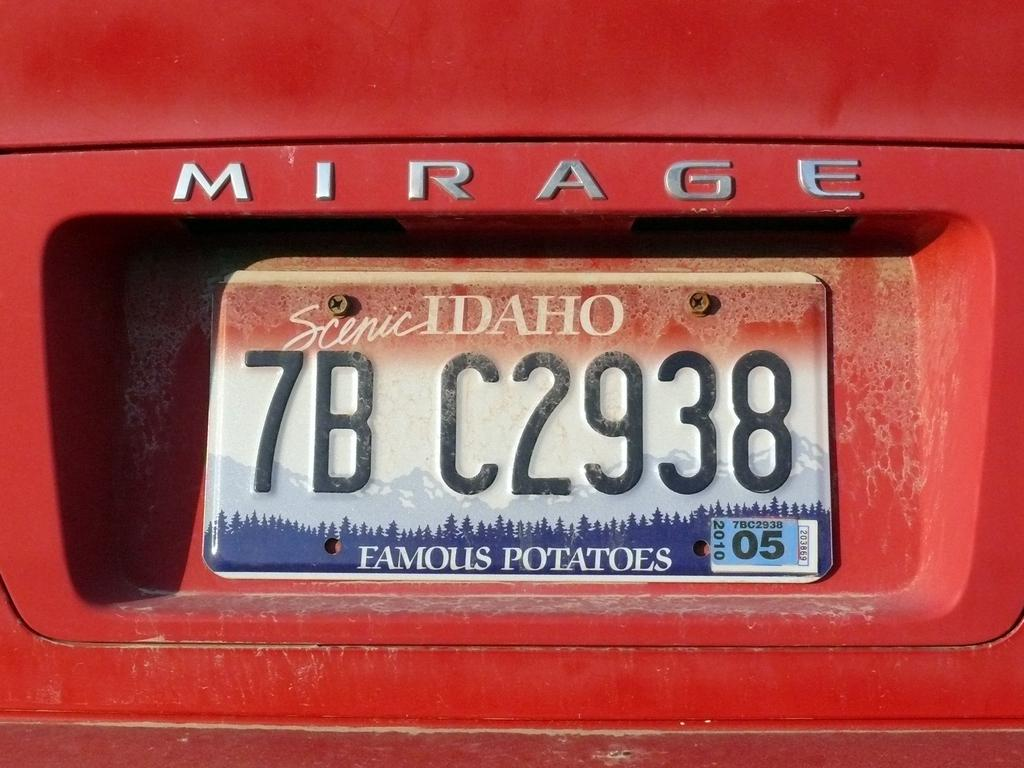<image>
Create a compact narrative representing the image presented. A red Mirage car has a Scenic Idaho license plate 7B C2938, with the slogan Famous Potatoes. 